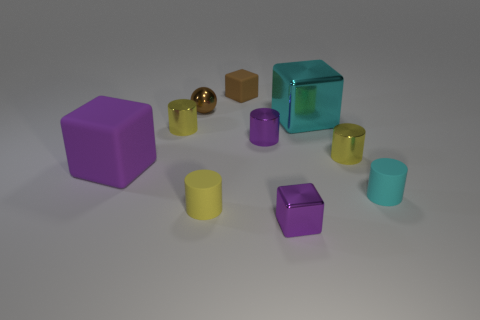Subtract all green balls. How many yellow cylinders are left? 3 Subtract 1 cylinders. How many cylinders are left? 4 Subtract all tiny purple metallic cylinders. How many cylinders are left? 4 Subtract all purple cylinders. How many cylinders are left? 4 Subtract all yellow cubes. Subtract all green cylinders. How many cubes are left? 4 Subtract all spheres. How many objects are left? 9 Subtract 0 purple balls. How many objects are left? 10 Subtract all large matte things. Subtract all blue rubber spheres. How many objects are left? 9 Add 7 small brown metal objects. How many small brown metal objects are left? 8 Add 1 brown objects. How many brown objects exist? 3 